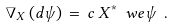Convert formula to latex. <formula><loc_0><loc_0><loc_500><loc_500>\nabla _ { X } \, ( d \psi ) \, = \, c \, X ^ { * } \ w e \psi \ .</formula> 